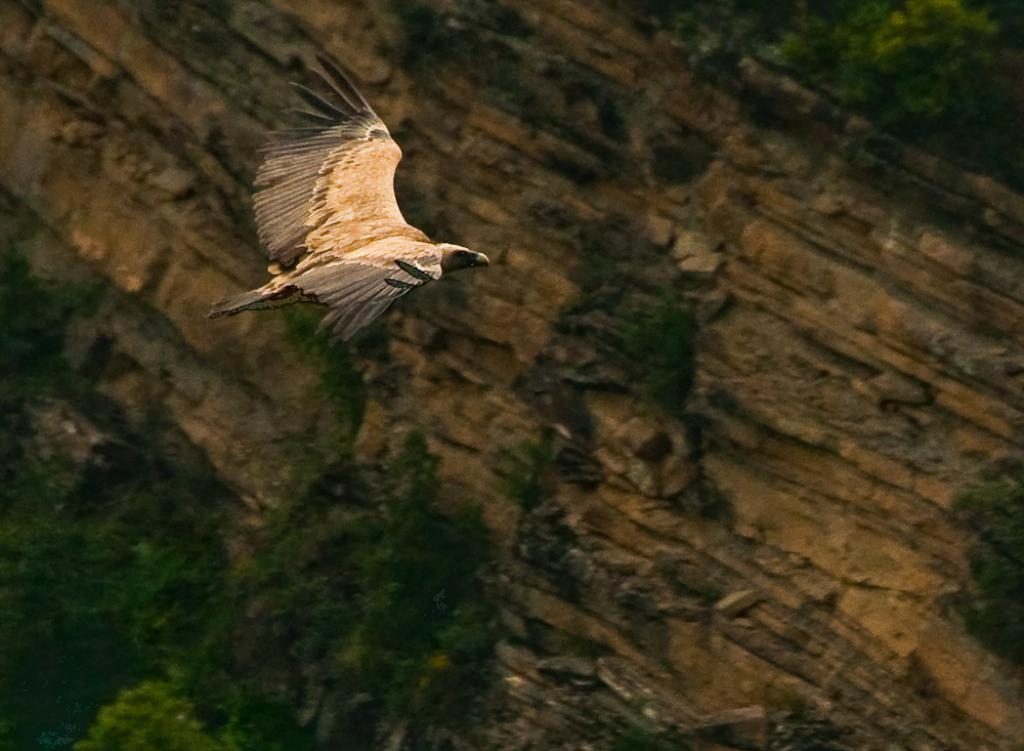Where was the picture taken? The picture was taken outside. What can be seen in the center of the image? There is a bird flying in the air in the center of the image. What type of vegetation is visible in the foreground of the image? Green leaves are visible in the foreground of the image. What else can be seen in the foreground of the image? There are other objects present in the foreground of the image. What type of eggnog is being served in the morning in the image? There is no eggnog or morning scene present in the image; it features a bird flying in the air and green leaves in the foreground. 